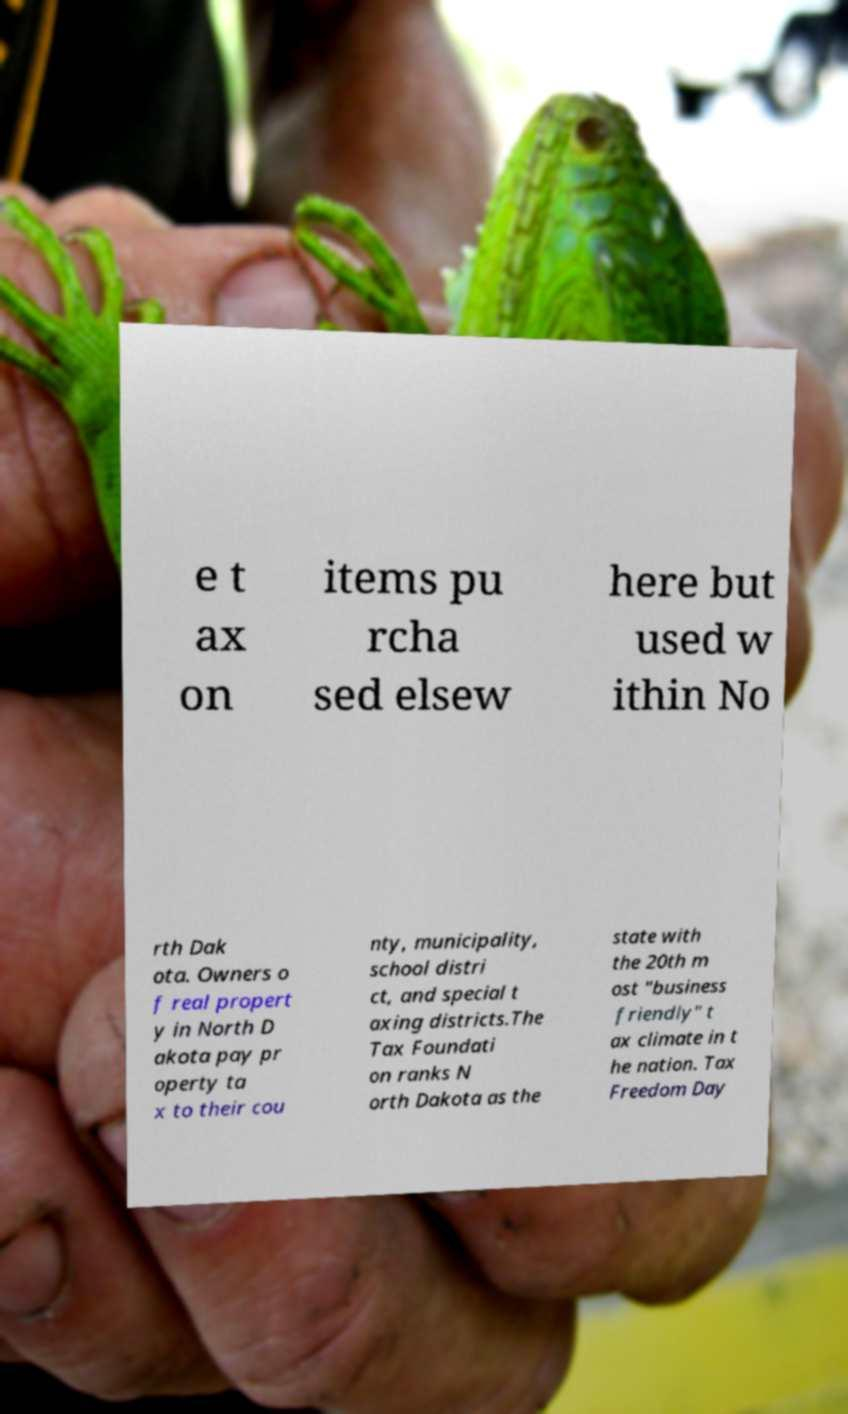Please identify and transcribe the text found in this image. e t ax on items pu rcha sed elsew here but used w ithin No rth Dak ota. Owners o f real propert y in North D akota pay pr operty ta x to their cou nty, municipality, school distri ct, and special t axing districts.The Tax Foundati on ranks N orth Dakota as the state with the 20th m ost "business friendly" t ax climate in t he nation. Tax Freedom Day 